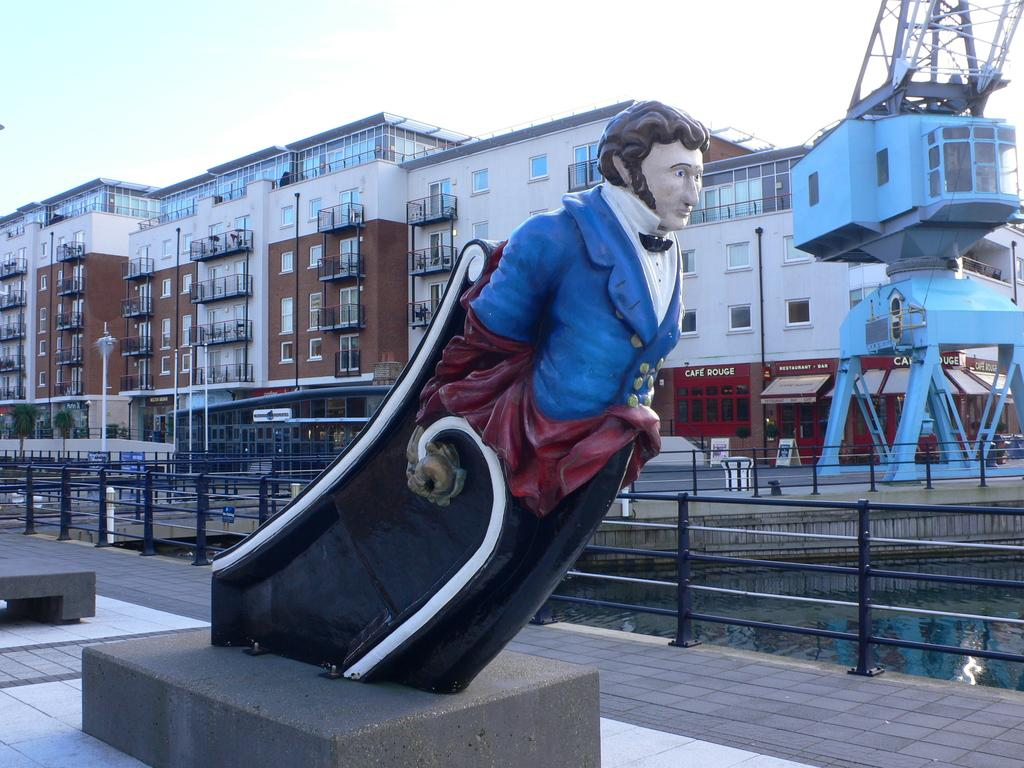What is the main subject on the platform in the image? There is a statue on a platform in the image. What can be seen in the image besides the statue? Water, fences, poles, trees, buildings with windows, and some objects are visible in the image. What is the purpose of the fences in the image? The purpose of the fences is not explicitly stated, but they may serve as a barrier or boundary. What is the condition of the sky in the background of the image? The sky is visible in the background of the image. What type of stamp can be seen on the statue in the image? There is no stamp visible on the statue in the image. How do the ants contribute to the maintenance of the trees in the image? There are no ants present in the image, so their contribution to the maintenance of the trees cannot be determined. 